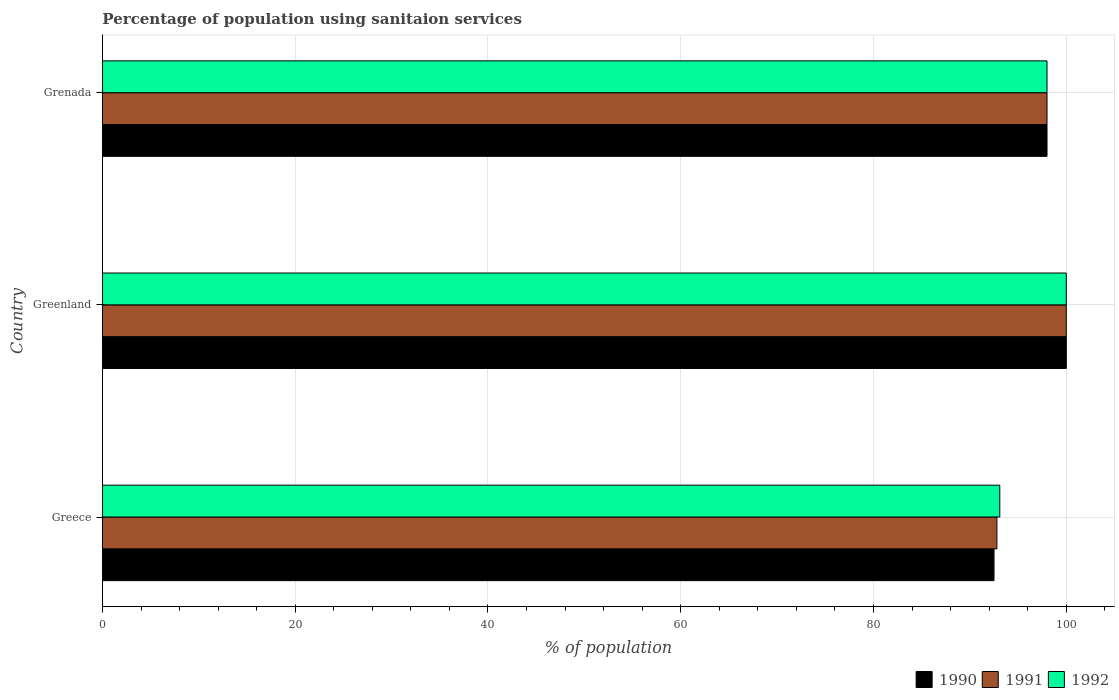How many different coloured bars are there?
Provide a succinct answer. 3. Are the number of bars per tick equal to the number of legend labels?
Offer a terse response. Yes. What is the label of the 2nd group of bars from the top?
Provide a succinct answer. Greenland. In how many cases, is the number of bars for a given country not equal to the number of legend labels?
Your answer should be very brief. 0. What is the percentage of population using sanitaion services in 1991 in Greenland?
Provide a short and direct response. 100. Across all countries, what is the maximum percentage of population using sanitaion services in 1992?
Ensure brevity in your answer.  100. Across all countries, what is the minimum percentage of population using sanitaion services in 1992?
Ensure brevity in your answer.  93.1. In which country was the percentage of population using sanitaion services in 1990 maximum?
Keep it short and to the point. Greenland. What is the total percentage of population using sanitaion services in 1992 in the graph?
Your response must be concise. 291.1. What is the difference between the percentage of population using sanitaion services in 1990 in Greenland and that in Grenada?
Offer a terse response. 2. What is the average percentage of population using sanitaion services in 1992 per country?
Ensure brevity in your answer.  97.03. What is the difference between the percentage of population using sanitaion services in 1990 and percentage of population using sanitaion services in 1992 in Greece?
Provide a short and direct response. -0.6. What is the ratio of the percentage of population using sanitaion services in 1990 in Greece to that in Greenland?
Ensure brevity in your answer.  0.93. Is the percentage of population using sanitaion services in 1990 in Greenland less than that in Grenada?
Provide a short and direct response. No. What is the difference between the highest and the second highest percentage of population using sanitaion services in 1992?
Provide a short and direct response. 2. In how many countries, is the percentage of population using sanitaion services in 1991 greater than the average percentage of population using sanitaion services in 1991 taken over all countries?
Provide a short and direct response. 2. Is the sum of the percentage of population using sanitaion services in 1991 in Greece and Grenada greater than the maximum percentage of population using sanitaion services in 1990 across all countries?
Your answer should be compact. Yes. What does the 2nd bar from the bottom in Greenland represents?
Your response must be concise. 1991. Is it the case that in every country, the sum of the percentage of population using sanitaion services in 1992 and percentage of population using sanitaion services in 1991 is greater than the percentage of population using sanitaion services in 1990?
Ensure brevity in your answer.  Yes. How many bars are there?
Your answer should be very brief. 9. What is the difference between two consecutive major ticks on the X-axis?
Keep it short and to the point. 20. Are the values on the major ticks of X-axis written in scientific E-notation?
Ensure brevity in your answer.  No. Does the graph contain grids?
Ensure brevity in your answer.  Yes. How many legend labels are there?
Keep it short and to the point. 3. What is the title of the graph?
Make the answer very short. Percentage of population using sanitaion services. Does "1993" appear as one of the legend labels in the graph?
Your answer should be compact. No. What is the label or title of the X-axis?
Provide a short and direct response. % of population. What is the label or title of the Y-axis?
Offer a terse response. Country. What is the % of population of 1990 in Greece?
Keep it short and to the point. 92.5. What is the % of population of 1991 in Greece?
Keep it short and to the point. 92.8. What is the % of population of 1992 in Greece?
Your answer should be very brief. 93.1. What is the % of population of 1991 in Greenland?
Make the answer very short. 100. What is the % of population in 1992 in Greenland?
Make the answer very short. 100. What is the % of population of 1990 in Grenada?
Keep it short and to the point. 98. What is the % of population of 1992 in Grenada?
Offer a very short reply. 98. Across all countries, what is the minimum % of population in 1990?
Ensure brevity in your answer.  92.5. Across all countries, what is the minimum % of population of 1991?
Make the answer very short. 92.8. Across all countries, what is the minimum % of population in 1992?
Ensure brevity in your answer.  93.1. What is the total % of population in 1990 in the graph?
Give a very brief answer. 290.5. What is the total % of population in 1991 in the graph?
Make the answer very short. 290.8. What is the total % of population in 1992 in the graph?
Make the answer very short. 291.1. What is the difference between the % of population in 1992 in Greece and that in Greenland?
Make the answer very short. -6.9. What is the difference between the % of population of 1990 in Greece and that in Grenada?
Offer a very short reply. -5.5. What is the difference between the % of population in 1991 in Greece and that in Grenada?
Ensure brevity in your answer.  -5.2. What is the difference between the % of population of 1990 in Greenland and that in Grenada?
Give a very brief answer. 2. What is the difference between the % of population in 1992 in Greenland and that in Grenada?
Offer a terse response. 2. What is the difference between the % of population of 1990 in Greece and the % of population of 1991 in Greenland?
Provide a short and direct response. -7.5. What is the difference between the % of population of 1990 in Greece and the % of population of 1992 in Greenland?
Provide a short and direct response. -7.5. What is the difference between the % of population of 1991 in Greece and the % of population of 1992 in Greenland?
Provide a succinct answer. -7.2. What is the difference between the % of population in 1991 in Greece and the % of population in 1992 in Grenada?
Your answer should be very brief. -5.2. What is the difference between the % of population in 1990 in Greenland and the % of population in 1991 in Grenada?
Make the answer very short. 2. What is the average % of population in 1990 per country?
Your answer should be very brief. 96.83. What is the average % of population in 1991 per country?
Offer a very short reply. 96.93. What is the average % of population in 1992 per country?
Offer a very short reply. 97.03. What is the difference between the % of population in 1991 and % of population in 1992 in Greece?
Your answer should be very brief. -0.3. What is the difference between the % of population of 1990 and % of population of 1992 in Greenland?
Offer a terse response. 0. What is the difference between the % of population in 1991 and % of population in 1992 in Greenland?
Give a very brief answer. 0. What is the difference between the % of population of 1990 and % of population of 1991 in Grenada?
Ensure brevity in your answer.  0. What is the difference between the % of population in 1990 and % of population in 1992 in Grenada?
Your answer should be very brief. 0. What is the difference between the % of population in 1991 and % of population in 1992 in Grenada?
Provide a succinct answer. 0. What is the ratio of the % of population in 1990 in Greece to that in Greenland?
Ensure brevity in your answer.  0.93. What is the ratio of the % of population in 1991 in Greece to that in Greenland?
Offer a very short reply. 0.93. What is the ratio of the % of population of 1992 in Greece to that in Greenland?
Your answer should be very brief. 0.93. What is the ratio of the % of population in 1990 in Greece to that in Grenada?
Your answer should be compact. 0.94. What is the ratio of the % of population of 1991 in Greece to that in Grenada?
Your answer should be compact. 0.95. What is the ratio of the % of population of 1992 in Greece to that in Grenada?
Keep it short and to the point. 0.95. What is the ratio of the % of population in 1990 in Greenland to that in Grenada?
Keep it short and to the point. 1.02. What is the ratio of the % of population of 1991 in Greenland to that in Grenada?
Ensure brevity in your answer.  1.02. What is the ratio of the % of population of 1992 in Greenland to that in Grenada?
Your answer should be very brief. 1.02. What is the difference between the highest and the second highest % of population in 1991?
Your answer should be compact. 2. What is the difference between the highest and the lowest % of population in 1990?
Ensure brevity in your answer.  7.5. What is the difference between the highest and the lowest % of population in 1991?
Offer a very short reply. 7.2. 